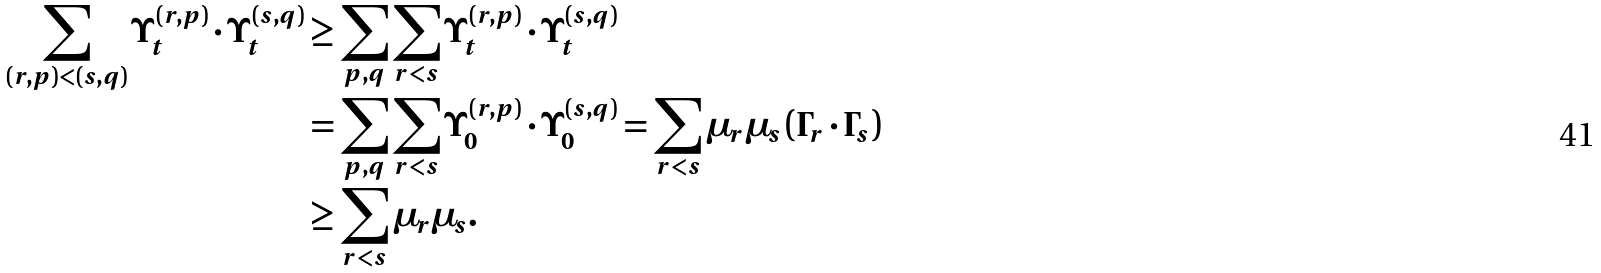Convert formula to latex. <formula><loc_0><loc_0><loc_500><loc_500>\sum _ { ( r , p ) < ( s , q ) } \Upsilon _ { t } ^ { ( r , p ) } \cdot \Upsilon _ { t } ^ { ( s , q ) } & \geq \sum _ { p , q } \sum _ { r < s } \Upsilon _ { t } ^ { ( r , p ) } \cdot \Upsilon _ { t } ^ { ( s , q ) } \\ & = \sum _ { p , q } \sum _ { r < s } \Upsilon _ { 0 } ^ { ( r , p ) } \cdot \Upsilon _ { 0 } ^ { ( s , q ) } = \sum _ { r < s } \mu _ { r } \mu _ { s } \left ( \Gamma _ { r } \cdot \Gamma _ { s } \right ) \\ & \geq \sum _ { r < s } \mu _ { r } \mu _ { s } .</formula> 